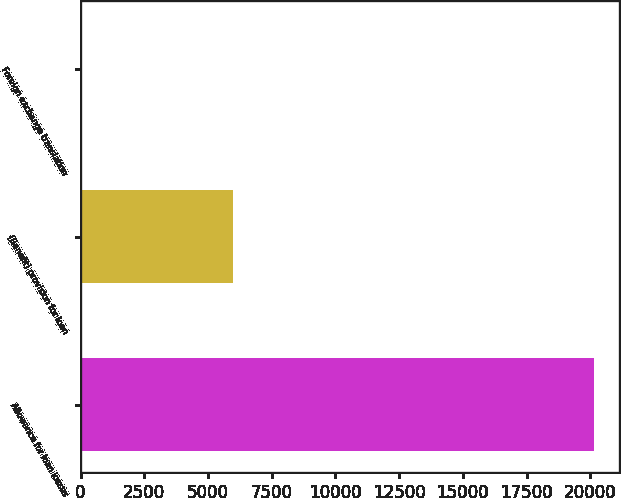Convert chart to OTSL. <chart><loc_0><loc_0><loc_500><loc_500><bar_chart><fcel>Allowance for loan losses<fcel>(Benefit) provision for loan<fcel>Foreign exchange translation<nl><fcel>20139<fcel>5998<fcel>37<nl></chart> 